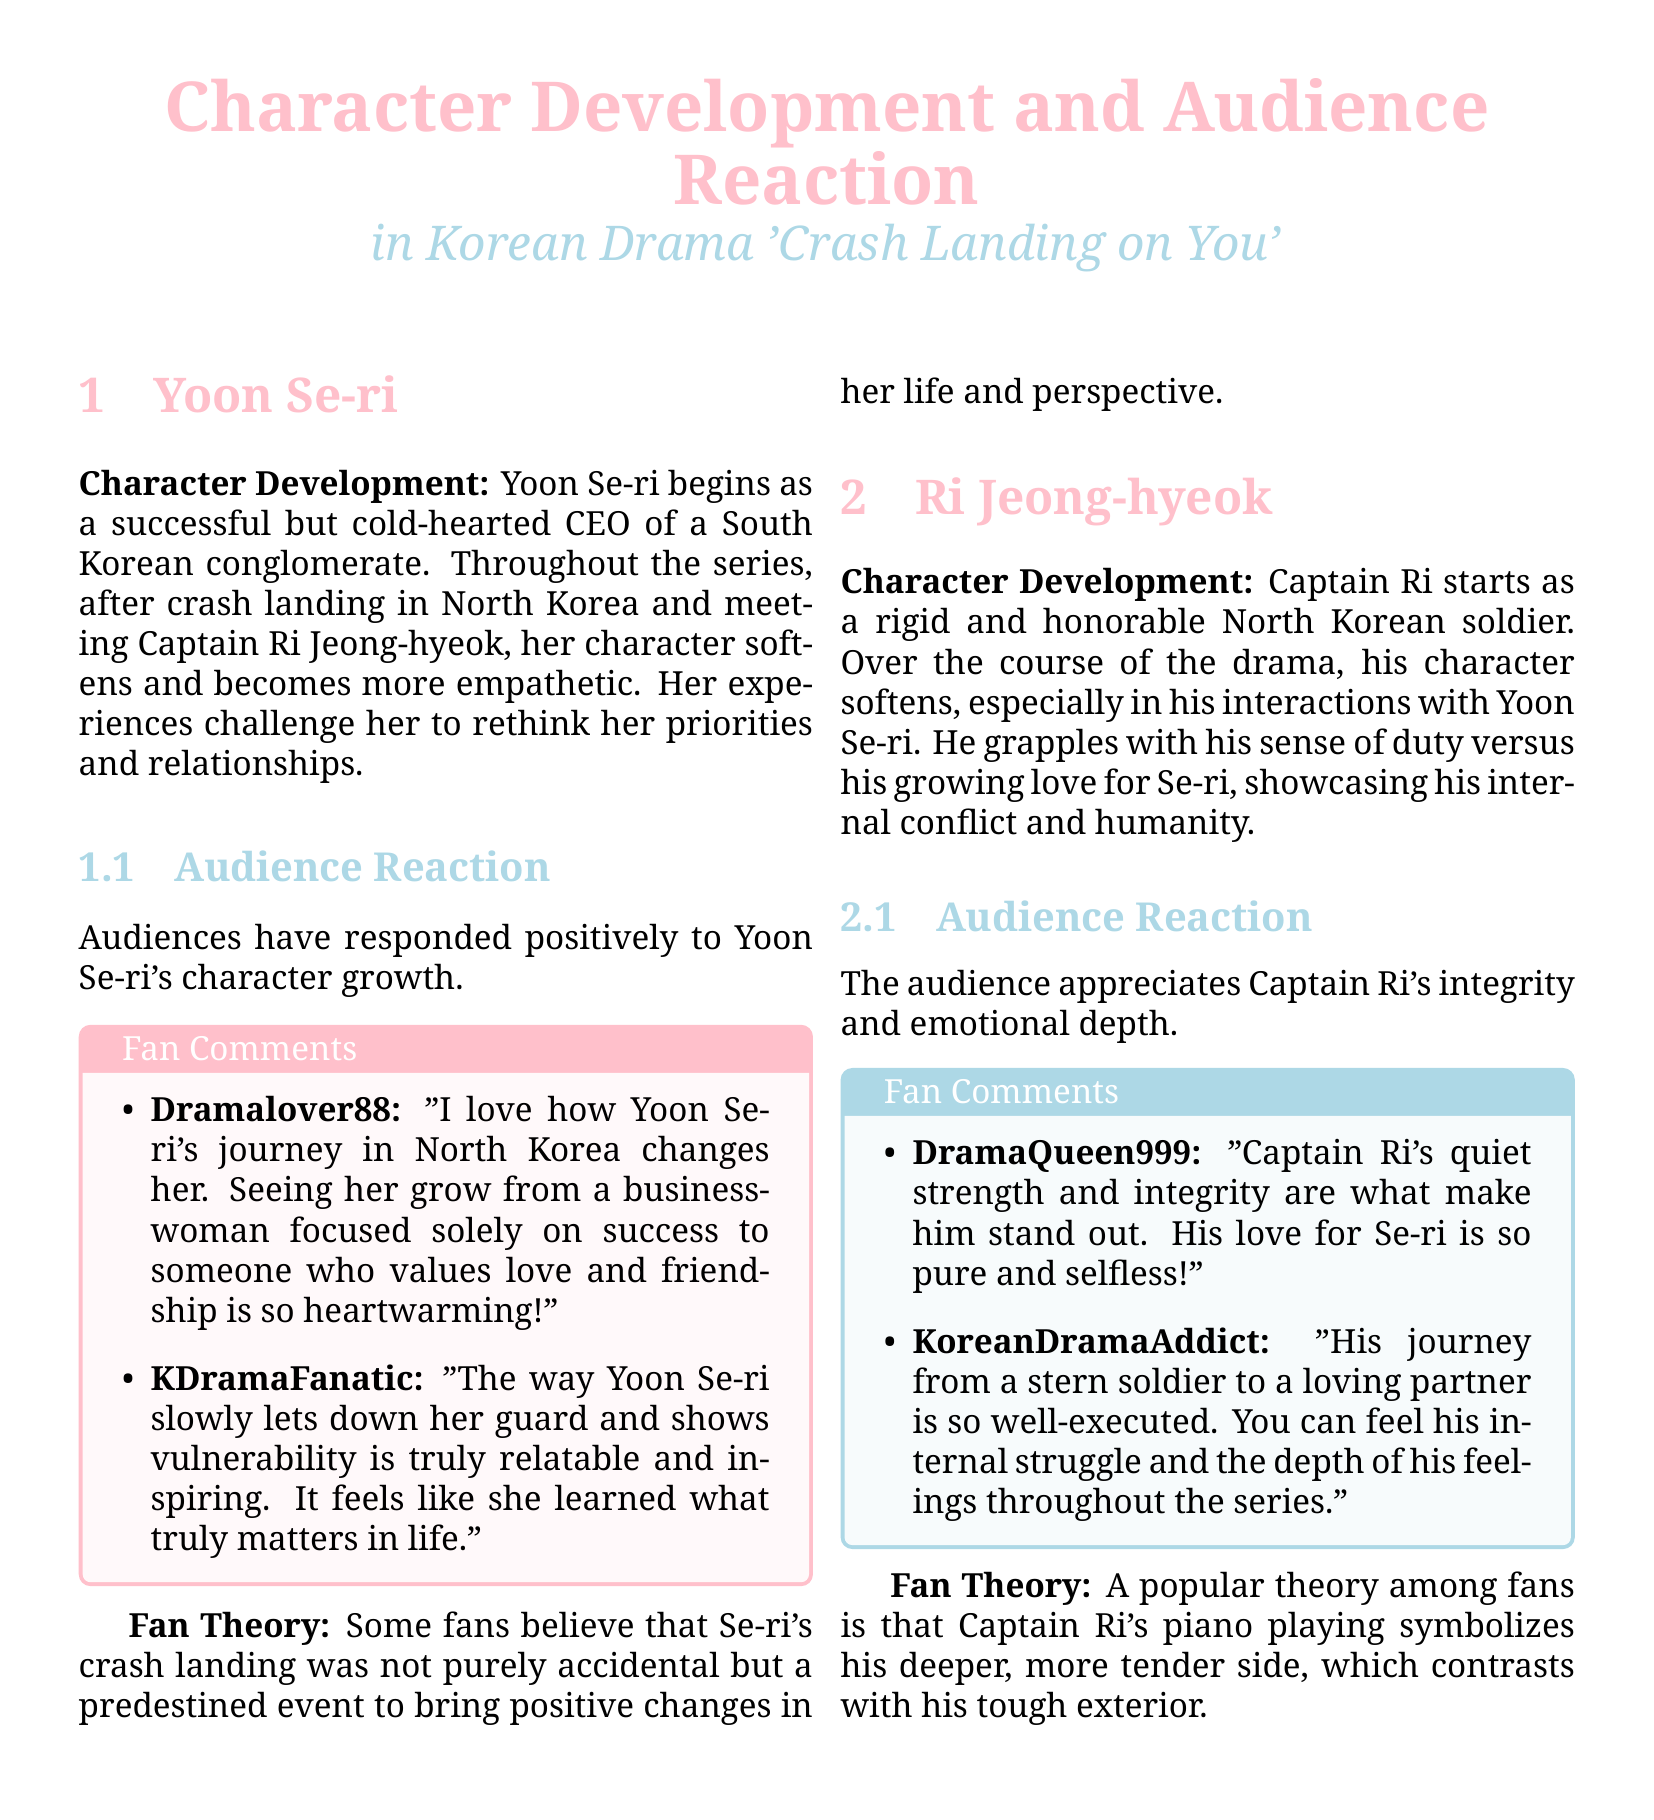What is the name of the female lead character? The document mentions Yoon Se-ri as the female lead character in the K-drama.
Answer: Yoon Se-ri What is the primary setting of the K-drama? The setting includes both South Korea and North Korea, as Yoon Se-ri crash lands in North Korea.
Answer: South Korea and North Korea How does Yoon Se-ri's character change throughout the series? Yoon Se-ri becomes more empathetic and values love and friendship, moving away from her cold-hearted CEO persona.
Answer: More empathetic What does Captain Ri Jeong-hyeok struggle with during the series? He struggles with his sense of duty versus his growing love for Yoon Se-ri.
Answer: Sense of duty versus love Which character symbolizes their tender side through piano playing? Captain Ri's piano playing symbolizes his deeper, more tender side.
Answer: Captain Ri What theory do fans have regarding Yoon Se-ri's crash landing? Fans theorize that her crash landing was predestined to bring positive changes in her life.
Answer: Predestined event What is the audience's reaction to Captain Ri's character? The audience appreciates Captain Ri's integrity and emotional depth.
Answer: Integrity and emotional depth Which audience comment describes Yoon Se-ri's growth as heartwarming? The comment from Dramalover88 describes her journey as heartwarming.
Answer: Dramalover88 How does Captain Ri's character initially appear to the audience? Captain Ri initially appears as a rigid and honorable North Korean soldier.
Answer: Rigid and honorable 